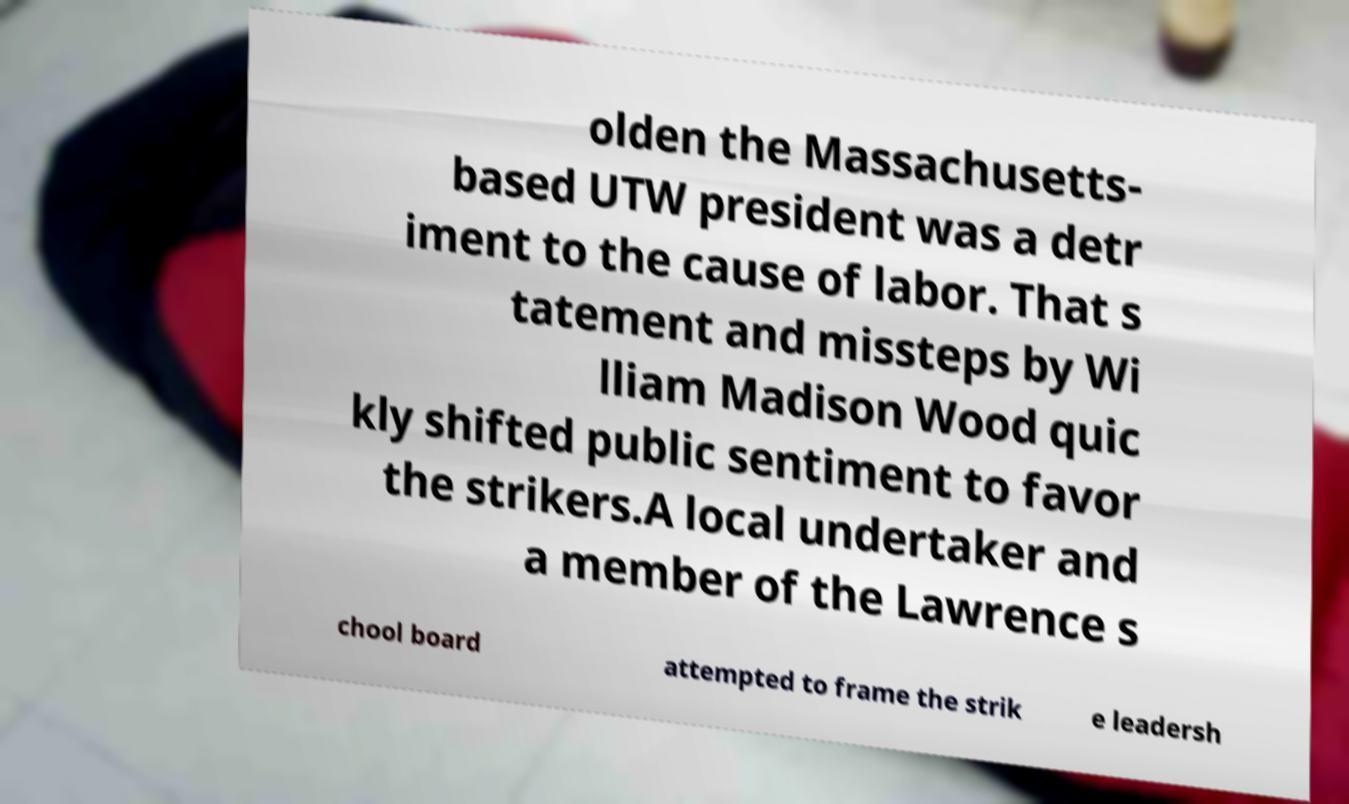Please read and relay the text visible in this image. What does it say? olden the Massachusetts- based UTW president was a detr iment to the cause of labor. That s tatement and missteps by Wi lliam Madison Wood quic kly shifted public sentiment to favor the strikers.A local undertaker and a member of the Lawrence s chool board attempted to frame the strik e leadersh 